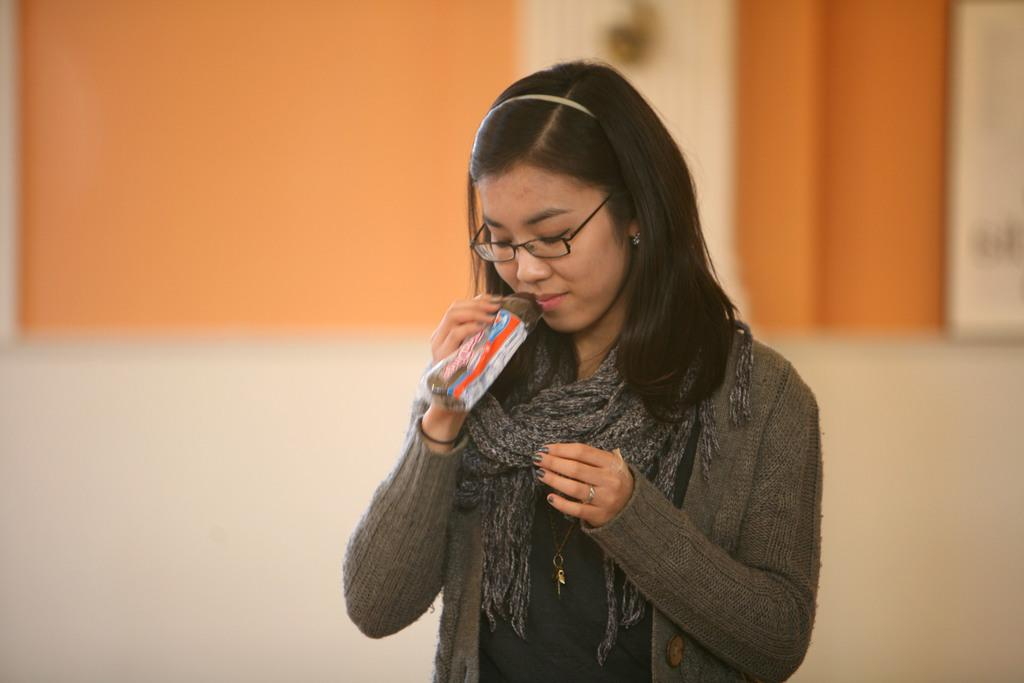Who is the main subject in the foreground of the image? There is a lady in the foreground of the image. What is the lady wearing in the image? The lady is wearing a jacket in the image. What can be seen in the background of the image? There is a wall in the background of the image. How many pins are attached to the board in the image? There is no board or pins present in the image. 